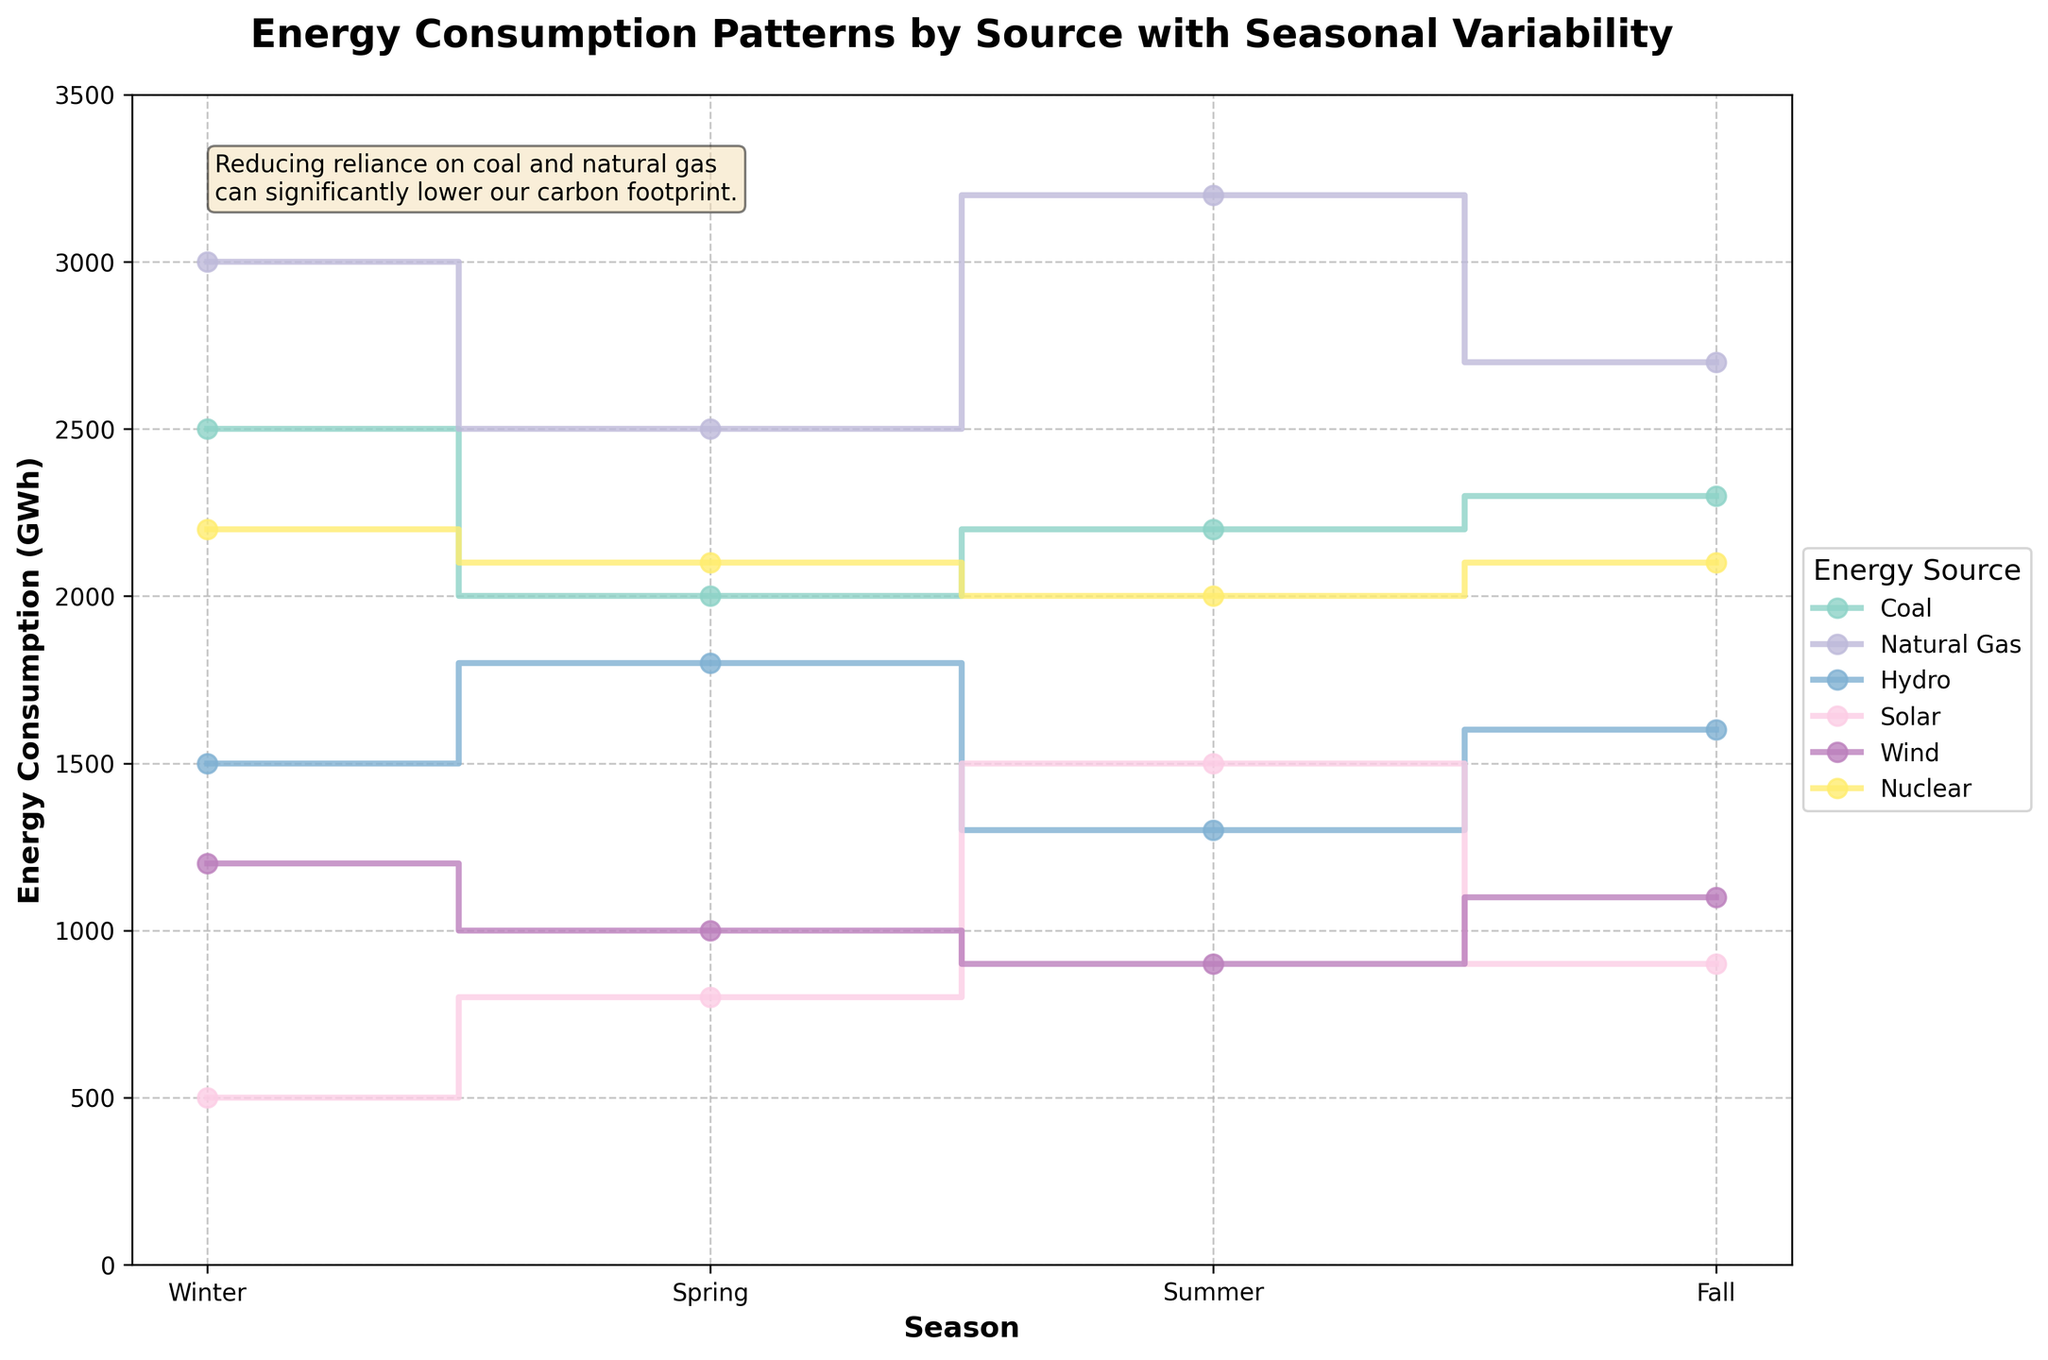What is the title of the figure? The title is prominently displayed at the top of the figure. It reads, "Energy Consumption Patterns by Source with Seasonal Variability".
Answer: Energy Consumption Patterns by Source with Seasonal Variability How many seasons are compared in the figure? The x-axis shows four distinct labels corresponding to the seasons. These labels are Winter, Spring, Summer, and Fall.
Answer: 4 Which energy source has the highest consumption in the summer? Looking at the summer season on the x-axis and checking the y-axis values for each energy source, Natural Gas reaches the highest consumption.
Answer: Natural Gas What is the combined energy consumption of Coal and Wind in Winter? In Winter, the y-axis shows Coal at 2500 GWh and Wind at 1200 GWh. Adding these together: 2500 + 1200 = 3700 GWh.
Answer: 3700 GWh Which season has the lowest consumption of Hydro energy? By comparing the y-axis values for Hydro across all seasons, Summer has the lowest value at 1300 GWh.
Answer: Summer Which two energy sources have the closest consumption values in Fall, and what are those values? In Fall, looking at the y-axis values for each energy source, Wind and Solar have consumption values of 1100 GWh and 900 GWh, respectively. The difference between them is minimal.
Answer: Wind: 1100 GWh, Solar: 900 GWh What is the average energy consumption of Natural Gas across all seasons? The y-axis values for Natural Gas for each season are: Winter: 3000 GWh, Spring: 2500 GWh, Summer: 3200 GWh, Fall: 2700 GWh. Adding these: 3000 + 2500 + 3200 + 2700 = 11400 GWh. Dividing by 4 seasons: 11400 / 4 = 2850 GWh.
Answer: 2850 GWh Between Nuclear and Solar, which energy source shows a greater variability (range) in consumption across the seasons? Nuclear values: 2200, 2100, 2000, 2100 (Range = 2200 - 2000 = 200). Solar values: 500, 800, 1500, 900 (Range = 1500 - 500 = 1000). Solar has a greater range.
Answer: Solar How does the consumption of Coal in Spring compare to its consumption in Fall? In Spring, the y-axis shows Coal consumption at 2000 GWh. In Fall, it is 2300 GWh. Fall is higher by 300 GWh.
Answer: Fall is higher by 300 GWh In which season does the combined consumption of Renewable sources (Hydro, Solar, Wind) peak? The sum of Renewable sources for each season is: Winter: 1500+500+1200=3200, Spring: 1800+800+1000=3600, Summer: 1300+1500+900=3700, Fall: 1600+900+1100=3600. The peak is in Summer.
Answer: Summer 